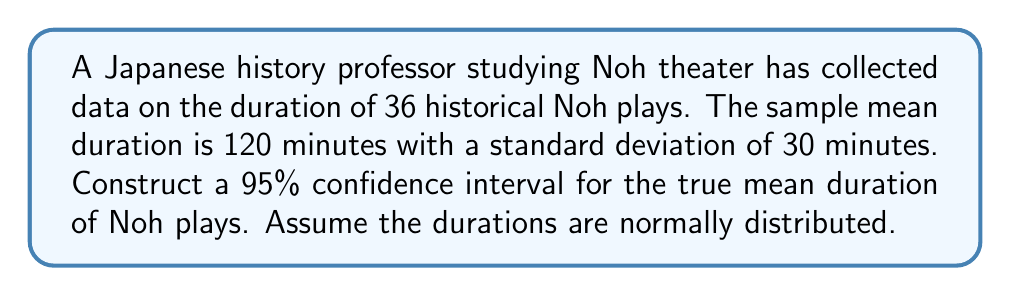Solve this math problem. To construct a 95% confidence interval for the mean duration of Noh plays, we'll follow these steps:

1) We're given:
   - Sample size: $n = 36$
   - Sample mean: $\bar{x} = 120$ minutes
   - Sample standard deviation: $s = 30$ minutes
   - Confidence level: 95%

2) For a 95% confidence interval, we use a $t$-distribution with $n-1 = 35$ degrees of freedom.
   The critical value is $t_{0.025, 35} = 2.030$ (from t-table or calculator).

3) The formula for the confidence interval is:

   $$\bar{x} \pm t_{\alpha/2, n-1} \cdot \frac{s}{\sqrt{n}}$$

4) Calculate the margin of error:

   $$\text{Margin of Error} = t_{\alpha/2, n-1} \cdot \frac{s}{\sqrt{n}} = 2.030 \cdot \frac{30}{\sqrt{36}} = 2.030 \cdot 5 = 10.15$$

5) Calculate the lower and upper bounds of the confidence interval:

   Lower bound: $120 - 10.15 = 109.85$
   Upper bound: $120 + 10.15 = 130.15$

Therefore, we can be 95% confident that the true mean duration of Noh plays falls between 109.85 and 130.15 minutes.
Answer: $(109.85, 130.15)$ minutes 